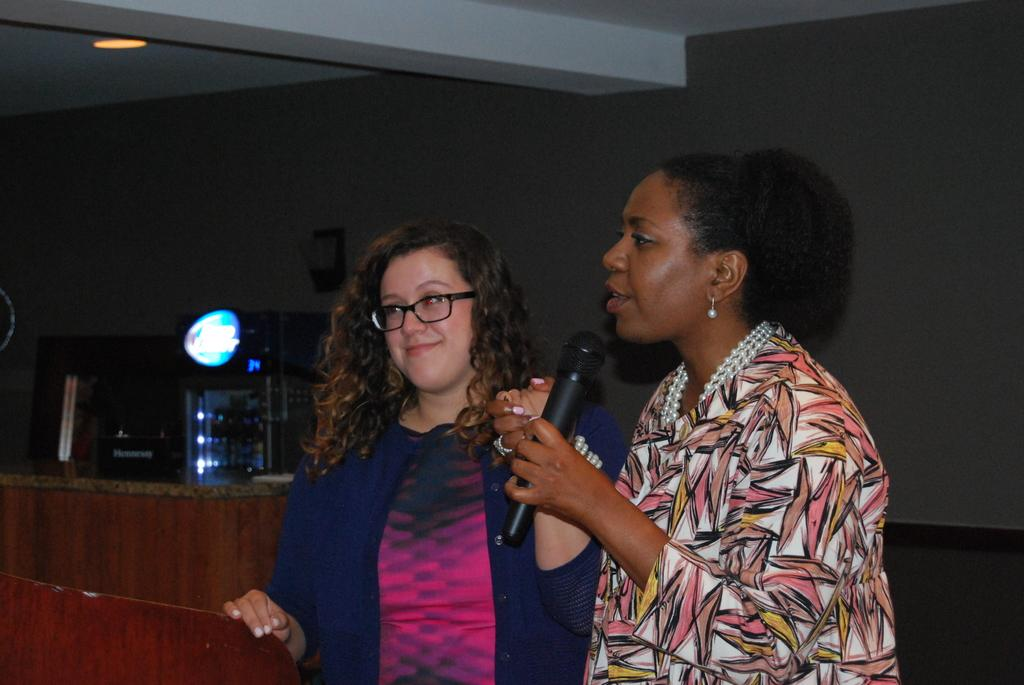How many people are in the image? There are two persons in the image. Where are the two persons located in the image? The two persons are standing in the background. What objects can be seen in the background of the image? There is a table and a light in the background of the image. Can you tell me how many cups are on the table in the image? There is no cup present on the table in the image. What type of place is depicted in the image? The image does not provide enough information to determine the type of place depicted. 